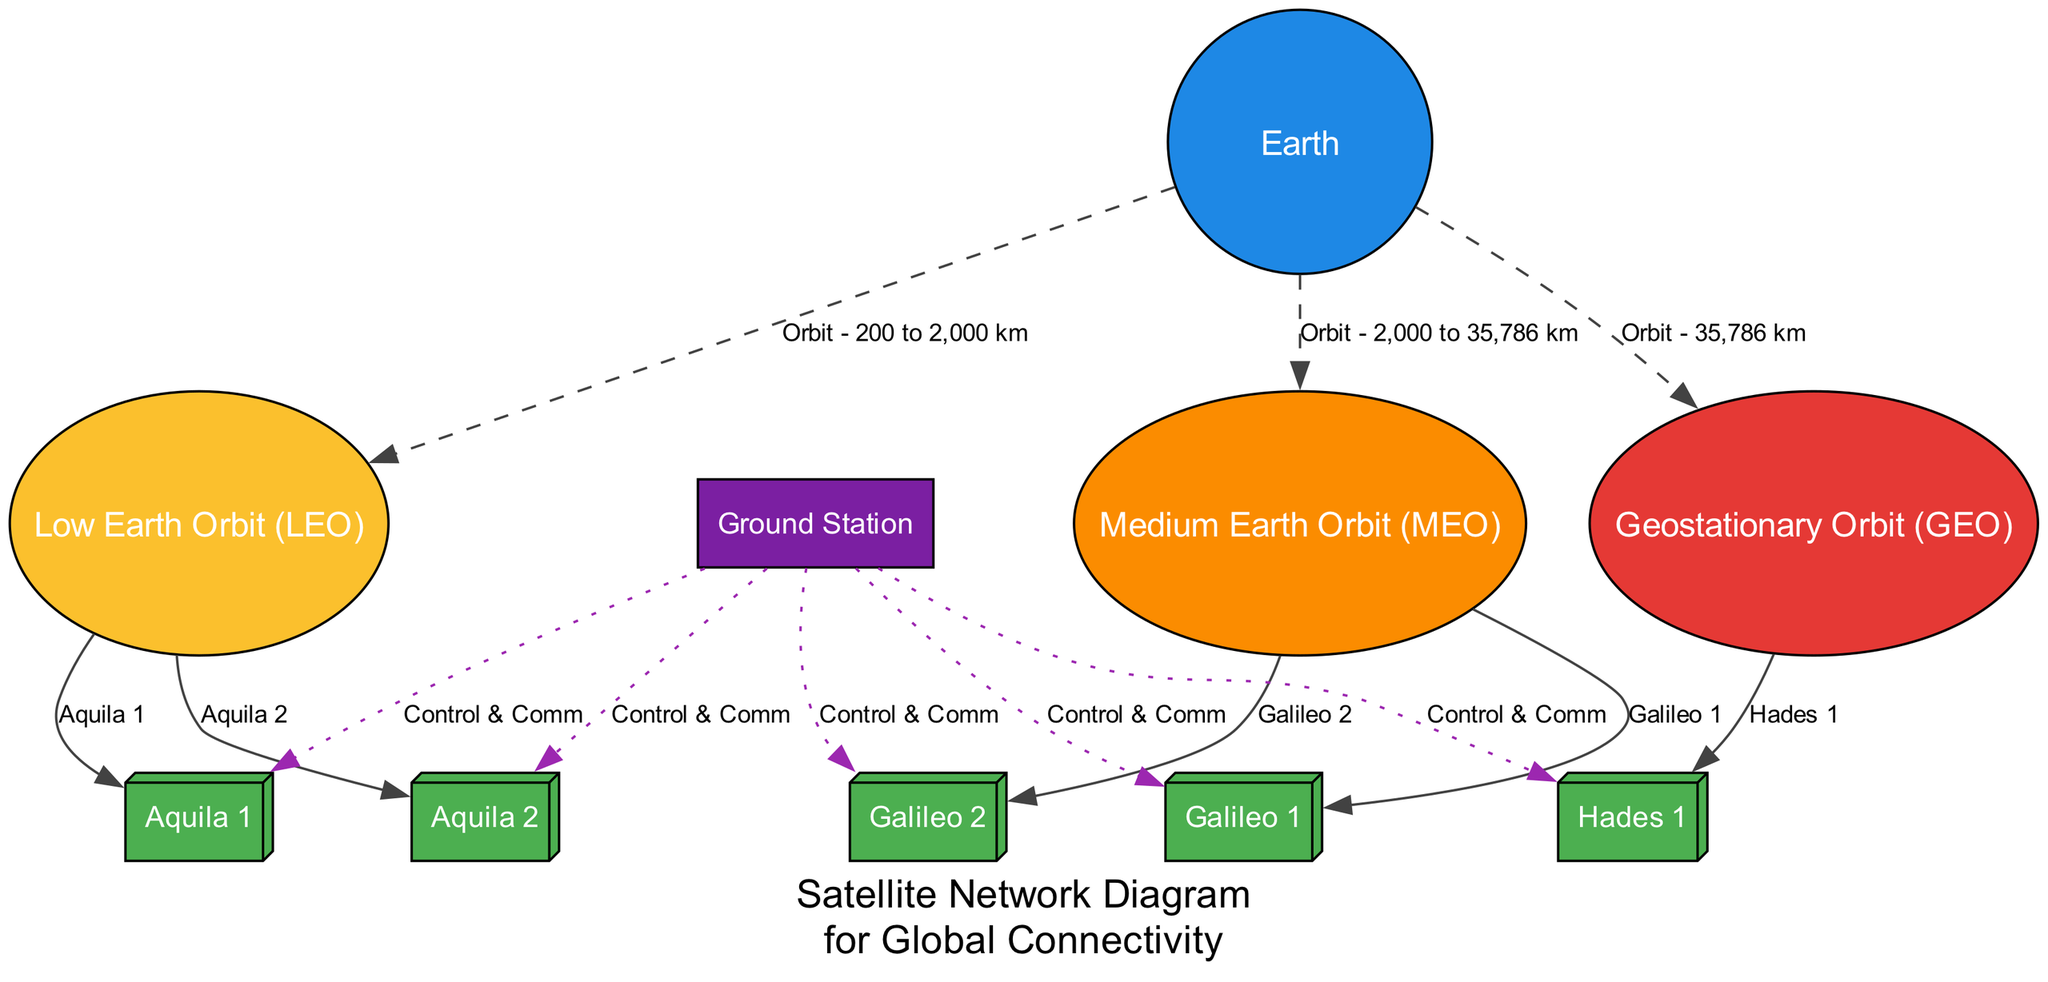What is the total number of nodes in the diagram? To find the total number of nodes, we count each unique node present in the data provided. The nodes are: Earth, Low Earth Orbit (LEO), Medium Earth Orbit (MEO), Geostationary Orbit (GEO), Aquila 1, Aquila 2, Galileo 1, Galileo 2, Hades 1, and Ground Station. That's a total of 10 nodes.
Answer: 10 Which satellite is in Geostationary Orbit? The diagram indicates one satellite specifically in Geostationary Orbit, which is Hades 1. Identifying the GEO node and then looking at the connection leads us directly to the satellite labeled Hades 1.
Answer: Hades 1 How many satellites are categorized under Low Earth Orbit? We examine the Low Earth Orbit node connections to determine how many satellites are associated with it. There are two satellites connected to this node: Aquila 1 and Aquila 2. Thus, there are two satellites in LEO.
Answer: 2 What is the purpose of the Ground Station in the diagram? The Ground Station connects to all the satellites within the diagram, as each edge indicates "Control & Comm" which signifies management and communication functions. Therefore, the purpose of the Ground Station is to manage and communicate with all the satellites.
Answer: Management and communication What is the orbit range for Medium Earth Orbit? The orbit range for Medium Earth Orbit is indicated as "2,000 to 35,786 km" in the relationship from Earth to the MEO node. This range reflects its positioning between Low Earth and Geostationary Orbits.
Answer: 2,000 to 35,786 km How many control and communication connections does the Ground Station have? We review the edges coming from the Ground Station and see that it connects to each of the five satellites (Aquila 1, Aquila 2, Galileo 1, Galileo 2, Hades 1) with control and communication labels. Thus, the Ground Station has five connections.
Answer: 5 Which orbit provides low-latency communications? Low Earth Orbit (LEO) is specifically described as providing low-latency communications in the diagram. Thus, LEO serves this key function in the network.
Answer: Low Earth Orbit What are the satellites in Medium Earth Orbit? By examining the connections from the Medium Earth Orbit node, we identify two satellites: Galileo 1 and Galileo 2 are both connected to this orbit. Therefore, these are the satellites designated for MEO.
Answer: Galileo 1, Galileo 2 What label describes the Earth to GEO connection? The diagram lists the label for the edge from Earth to Geostationary Orbit as "Orbit - 35,786 km". This indicates the distance at which the GEO satellites operate.
Answer: Orbit - 35,786 km 